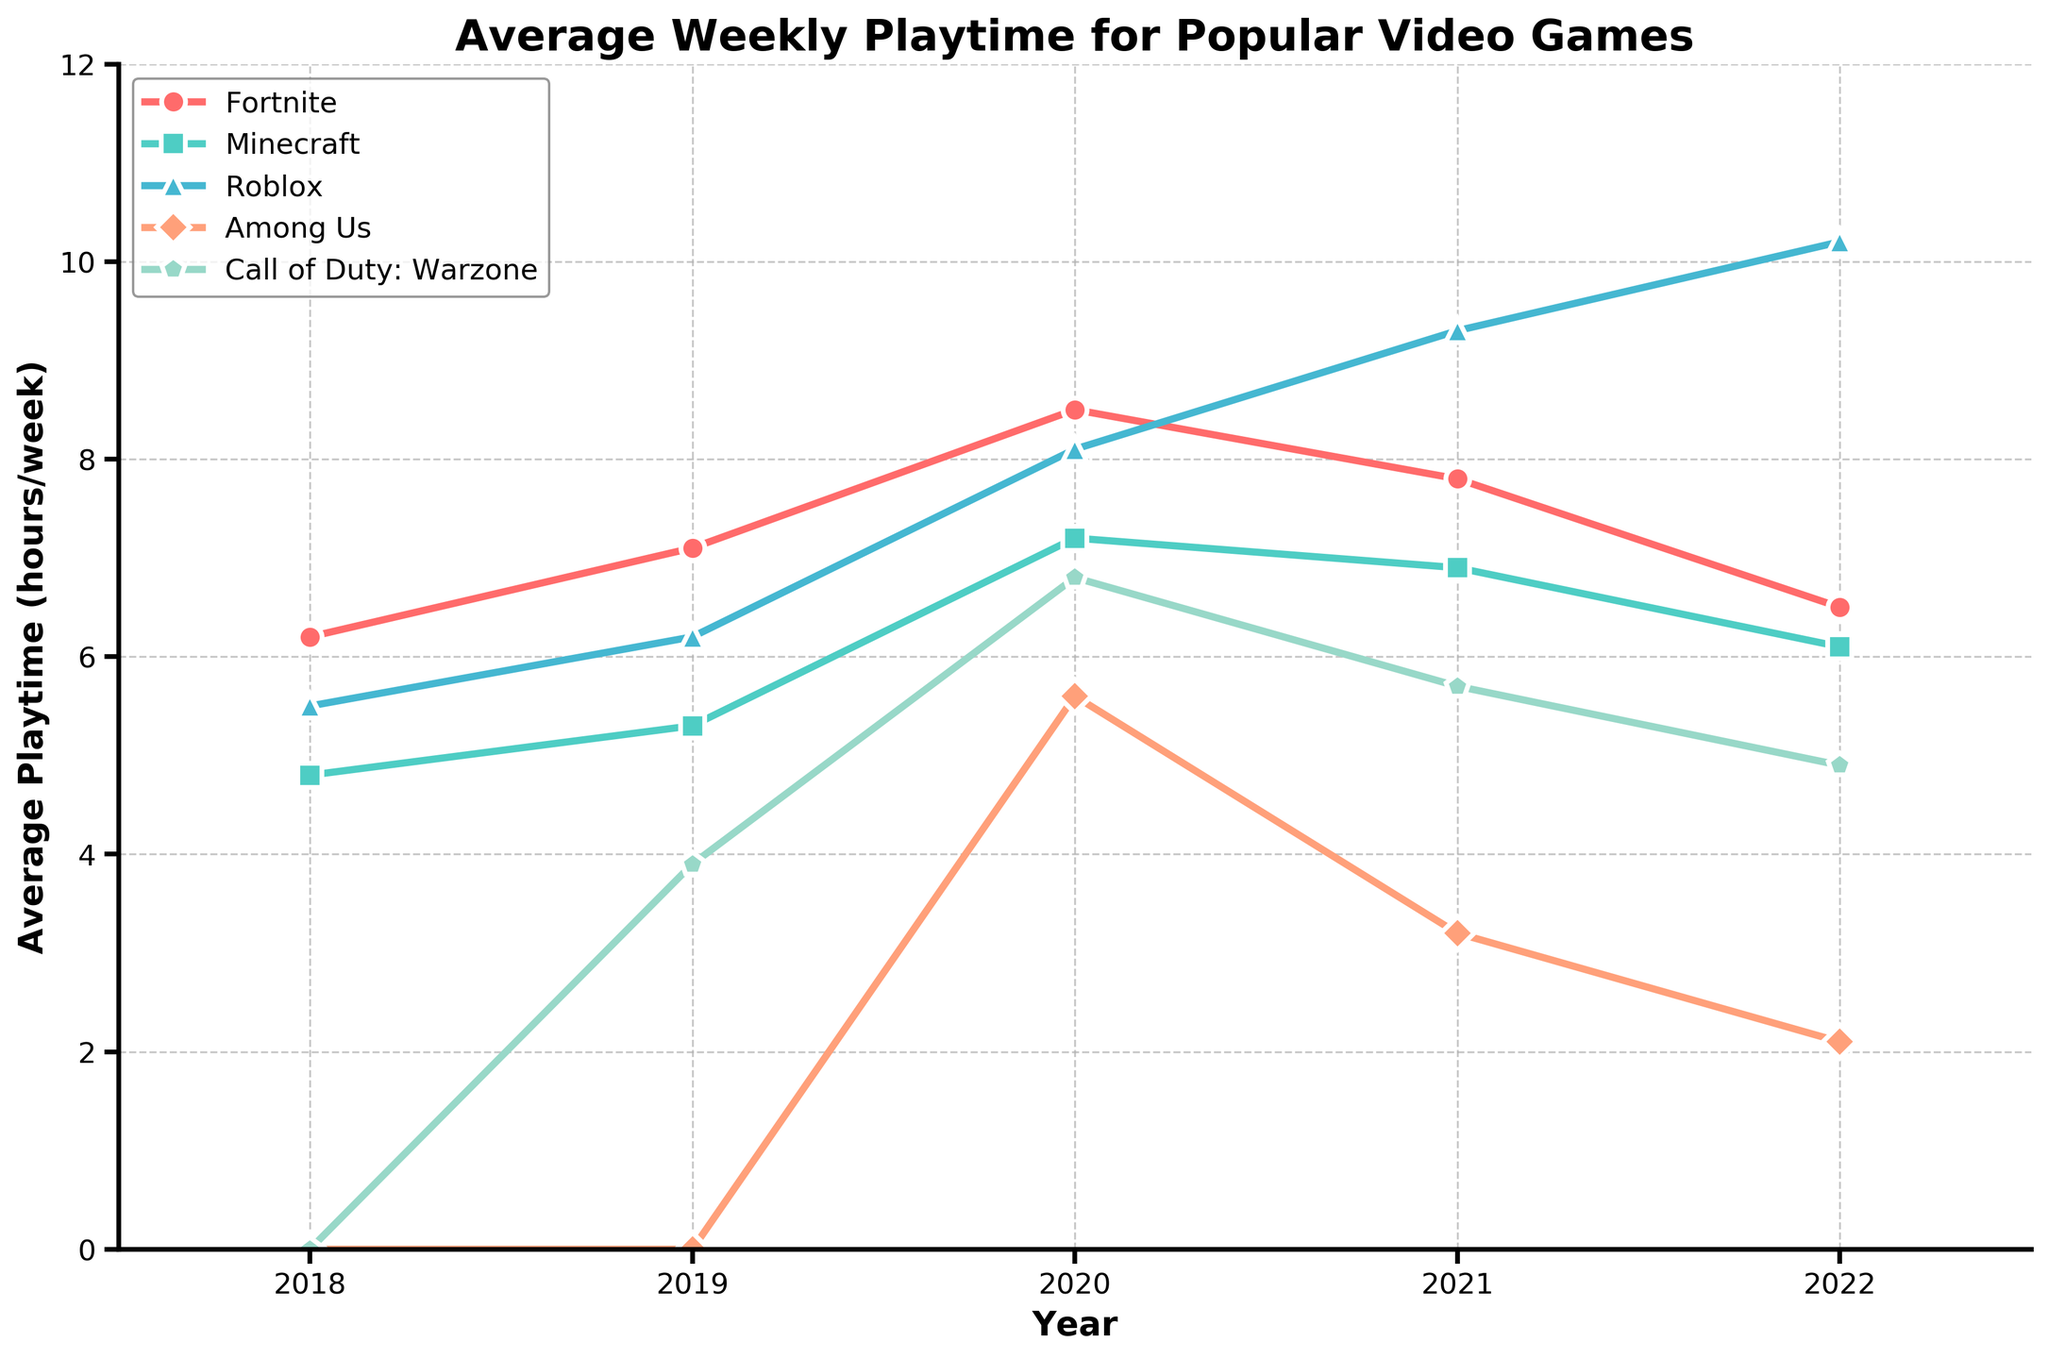What is the average playtime for Fortnite in the year 2020? The playtime for Fortnite in 2020 is visible on the plot.
Answer: 8.5 hours/week Which game had the highest average playtime in 2022? The plot shows that Roblox has the highest average playtime in 2022.
Answer: Roblox Did Minecraft’s playtime increase or decrease from 2021 to 2022? By comparing the points for Minecraft in 2021 (6.9) and 2022 (6.1), one can see a decrease.
Answer: Decrease What was Among Us' average playtime when it first appeared on the chart? Among Us first appears on the chart in 2020 with an average playtime value.
Answer: 5.6 hours/week Which game maintained a consistent increase in average playtime from 2018 to 2022? Roblox shows a consistent increase each year from 2018 to 2022 on the plot.
Answer: Roblox In which year did Call of Duty: Warzone have its highest average playtime? The highest point for Call of Duty: Warzone on the plot is in 2020.
Answer: 2020 Compare the average playtime of Roblox and Among Us in 2021. Which one was higher? The plot shows the average playtime for Roblox (9.3) and Among Us (3.2) in 2021.
Answer: Roblox How many hours more did Fortnite players play on average in 2019 compared to 2018? In 2019, Fortnite’s playtime was 7.1 hours, and in 2018 it was 6.2 hours. The difference is 7.1 - 6.2.
Answer: 0.9 hours What is the difference in average playtime between Fortnite and Roblox in 2022? The plot shows the playtime for Fortnite (6.5) and Roblox (10.2) in 2022. The difference is 10.2 - 6.5.
Answer: 3.7 hours Which game had the lowest average playtime in 2020? Among the games shown, Among Us has the lowest playtime value in 2020.
Answer: Among Us 